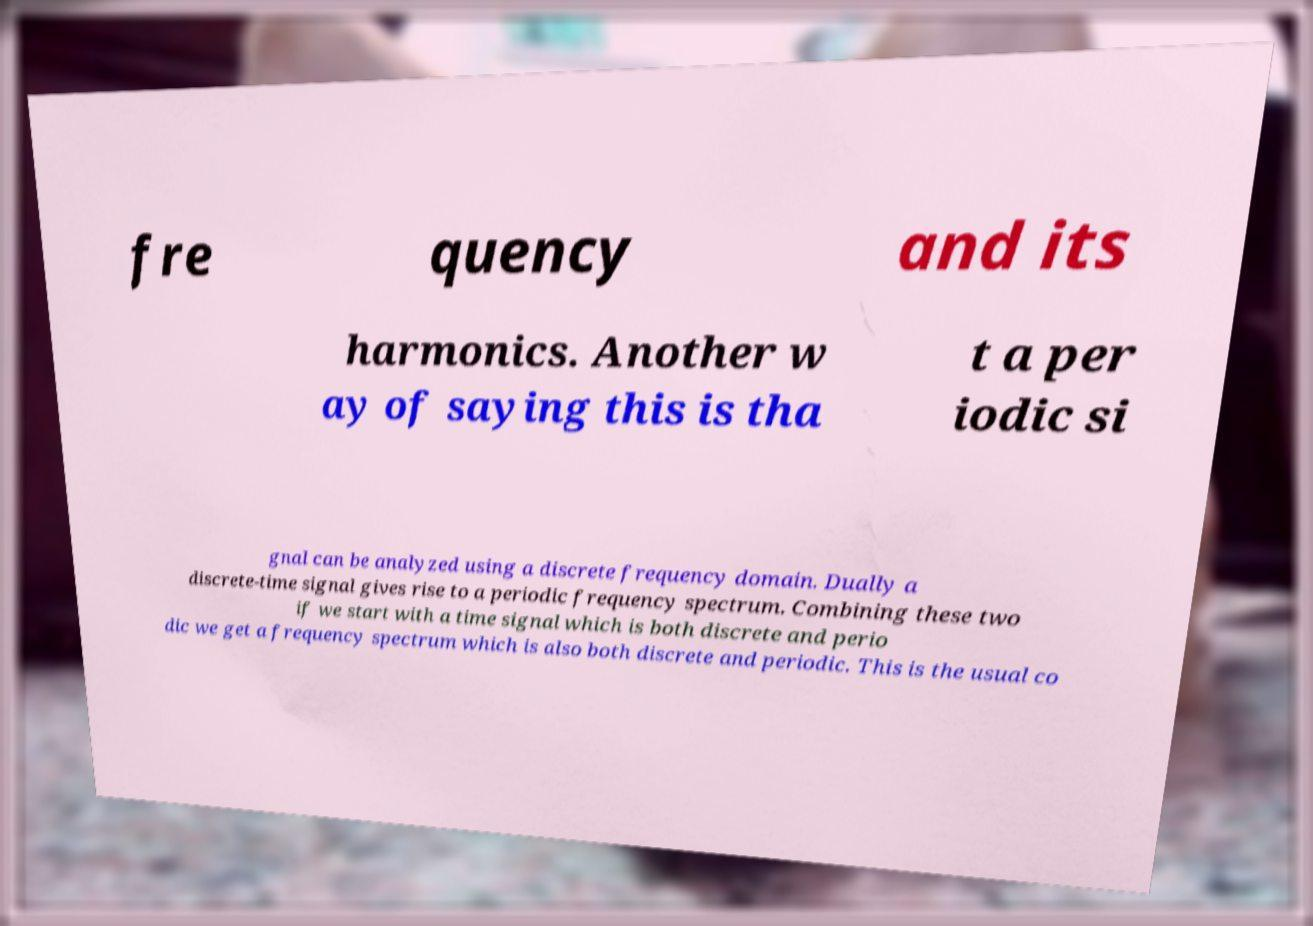For documentation purposes, I need the text within this image transcribed. Could you provide that? fre quency and its harmonics. Another w ay of saying this is tha t a per iodic si gnal can be analyzed using a discrete frequency domain. Dually a discrete-time signal gives rise to a periodic frequency spectrum. Combining these two if we start with a time signal which is both discrete and perio dic we get a frequency spectrum which is also both discrete and periodic. This is the usual co 